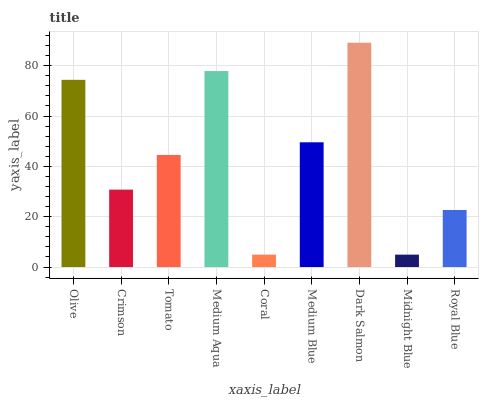Is Crimson the minimum?
Answer yes or no. No. Is Crimson the maximum?
Answer yes or no. No. Is Olive greater than Crimson?
Answer yes or no. Yes. Is Crimson less than Olive?
Answer yes or no. Yes. Is Crimson greater than Olive?
Answer yes or no. No. Is Olive less than Crimson?
Answer yes or no. No. Is Tomato the high median?
Answer yes or no. Yes. Is Tomato the low median?
Answer yes or no. Yes. Is Medium Aqua the high median?
Answer yes or no. No. Is Crimson the low median?
Answer yes or no. No. 